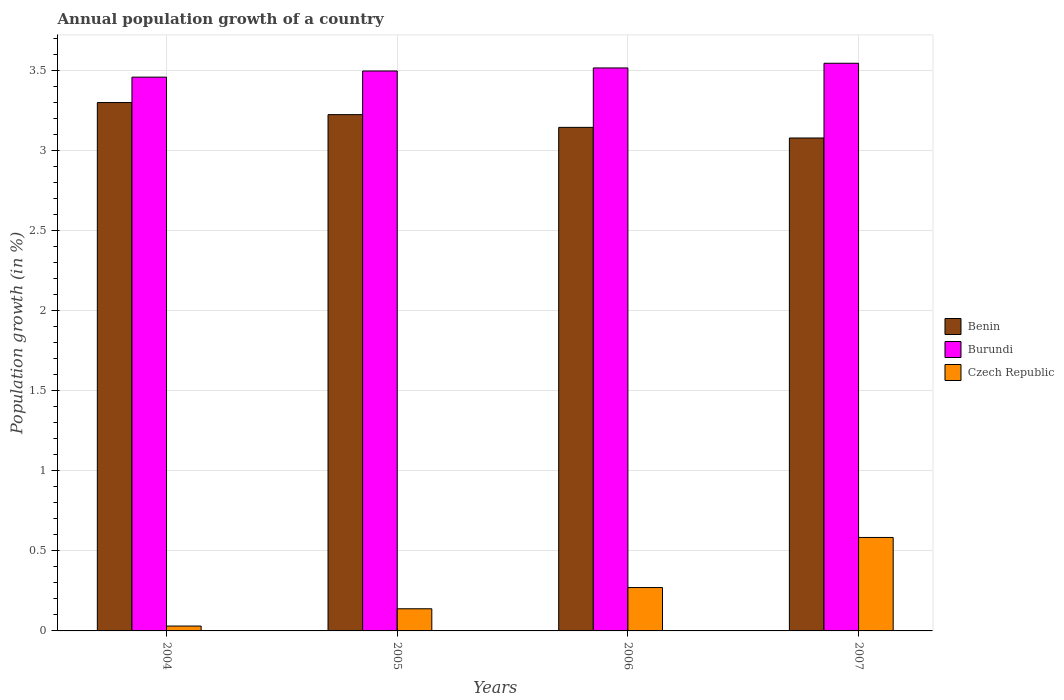Are the number of bars per tick equal to the number of legend labels?
Provide a short and direct response. Yes. How many bars are there on the 4th tick from the right?
Your response must be concise. 3. What is the annual population growth in Burundi in 2005?
Keep it short and to the point. 3.5. Across all years, what is the maximum annual population growth in Benin?
Give a very brief answer. 3.3. Across all years, what is the minimum annual population growth in Burundi?
Give a very brief answer. 3.46. What is the total annual population growth in Czech Republic in the graph?
Ensure brevity in your answer.  1.02. What is the difference between the annual population growth in Czech Republic in 2005 and that in 2006?
Provide a short and direct response. -0.13. What is the difference between the annual population growth in Burundi in 2007 and the annual population growth in Czech Republic in 2006?
Provide a short and direct response. 3.27. What is the average annual population growth in Czech Republic per year?
Offer a very short reply. 0.26. In the year 2007, what is the difference between the annual population growth in Czech Republic and annual population growth in Burundi?
Offer a very short reply. -2.96. In how many years, is the annual population growth in Benin greater than 1.8 %?
Give a very brief answer. 4. What is the ratio of the annual population growth in Burundi in 2004 to that in 2006?
Make the answer very short. 0.98. Is the difference between the annual population growth in Czech Republic in 2005 and 2007 greater than the difference between the annual population growth in Burundi in 2005 and 2007?
Offer a very short reply. No. What is the difference between the highest and the second highest annual population growth in Czech Republic?
Offer a terse response. 0.31. What is the difference between the highest and the lowest annual population growth in Benin?
Offer a very short reply. 0.22. What does the 1st bar from the left in 2006 represents?
Your answer should be compact. Benin. What does the 2nd bar from the right in 2004 represents?
Your response must be concise. Burundi. Is it the case that in every year, the sum of the annual population growth in Burundi and annual population growth in Benin is greater than the annual population growth in Czech Republic?
Your response must be concise. Yes. How many bars are there?
Your answer should be compact. 12. How many years are there in the graph?
Provide a short and direct response. 4. What is the difference between two consecutive major ticks on the Y-axis?
Keep it short and to the point. 0.5. Are the values on the major ticks of Y-axis written in scientific E-notation?
Give a very brief answer. No. Does the graph contain any zero values?
Give a very brief answer. No. Where does the legend appear in the graph?
Keep it short and to the point. Center right. What is the title of the graph?
Give a very brief answer. Annual population growth of a country. What is the label or title of the X-axis?
Provide a succinct answer. Years. What is the label or title of the Y-axis?
Provide a succinct answer. Population growth (in %). What is the Population growth (in %) of Benin in 2004?
Offer a very short reply. 3.3. What is the Population growth (in %) of Burundi in 2004?
Ensure brevity in your answer.  3.46. What is the Population growth (in %) of Czech Republic in 2004?
Offer a very short reply. 0.03. What is the Population growth (in %) of Benin in 2005?
Provide a succinct answer. 3.22. What is the Population growth (in %) of Burundi in 2005?
Keep it short and to the point. 3.5. What is the Population growth (in %) of Czech Republic in 2005?
Make the answer very short. 0.14. What is the Population growth (in %) in Benin in 2006?
Your answer should be very brief. 3.14. What is the Population growth (in %) in Burundi in 2006?
Make the answer very short. 3.52. What is the Population growth (in %) of Czech Republic in 2006?
Make the answer very short. 0.27. What is the Population growth (in %) of Benin in 2007?
Provide a succinct answer. 3.08. What is the Population growth (in %) in Burundi in 2007?
Your response must be concise. 3.54. What is the Population growth (in %) of Czech Republic in 2007?
Ensure brevity in your answer.  0.58. Across all years, what is the maximum Population growth (in %) in Benin?
Provide a succinct answer. 3.3. Across all years, what is the maximum Population growth (in %) in Burundi?
Your answer should be very brief. 3.54. Across all years, what is the maximum Population growth (in %) in Czech Republic?
Provide a short and direct response. 0.58. Across all years, what is the minimum Population growth (in %) of Benin?
Offer a very short reply. 3.08. Across all years, what is the minimum Population growth (in %) of Burundi?
Your response must be concise. 3.46. Across all years, what is the minimum Population growth (in %) of Czech Republic?
Provide a short and direct response. 0.03. What is the total Population growth (in %) in Benin in the graph?
Keep it short and to the point. 12.74. What is the total Population growth (in %) of Burundi in the graph?
Give a very brief answer. 14.01. What is the total Population growth (in %) in Czech Republic in the graph?
Your answer should be compact. 1.02. What is the difference between the Population growth (in %) of Benin in 2004 and that in 2005?
Offer a terse response. 0.08. What is the difference between the Population growth (in %) of Burundi in 2004 and that in 2005?
Your response must be concise. -0.04. What is the difference between the Population growth (in %) in Czech Republic in 2004 and that in 2005?
Provide a short and direct response. -0.11. What is the difference between the Population growth (in %) in Benin in 2004 and that in 2006?
Your answer should be compact. 0.15. What is the difference between the Population growth (in %) in Burundi in 2004 and that in 2006?
Provide a succinct answer. -0.06. What is the difference between the Population growth (in %) of Czech Republic in 2004 and that in 2006?
Provide a succinct answer. -0.24. What is the difference between the Population growth (in %) of Benin in 2004 and that in 2007?
Your answer should be compact. 0.22. What is the difference between the Population growth (in %) in Burundi in 2004 and that in 2007?
Provide a short and direct response. -0.09. What is the difference between the Population growth (in %) in Czech Republic in 2004 and that in 2007?
Offer a terse response. -0.55. What is the difference between the Population growth (in %) of Benin in 2005 and that in 2006?
Provide a succinct answer. 0.08. What is the difference between the Population growth (in %) of Burundi in 2005 and that in 2006?
Make the answer very short. -0.02. What is the difference between the Population growth (in %) in Czech Republic in 2005 and that in 2006?
Make the answer very short. -0.13. What is the difference between the Population growth (in %) in Benin in 2005 and that in 2007?
Keep it short and to the point. 0.15. What is the difference between the Population growth (in %) of Burundi in 2005 and that in 2007?
Your answer should be compact. -0.05. What is the difference between the Population growth (in %) in Czech Republic in 2005 and that in 2007?
Provide a succinct answer. -0.45. What is the difference between the Population growth (in %) of Benin in 2006 and that in 2007?
Keep it short and to the point. 0.07. What is the difference between the Population growth (in %) in Burundi in 2006 and that in 2007?
Provide a succinct answer. -0.03. What is the difference between the Population growth (in %) of Czech Republic in 2006 and that in 2007?
Ensure brevity in your answer.  -0.31. What is the difference between the Population growth (in %) of Benin in 2004 and the Population growth (in %) of Burundi in 2005?
Offer a very short reply. -0.2. What is the difference between the Population growth (in %) in Benin in 2004 and the Population growth (in %) in Czech Republic in 2005?
Provide a succinct answer. 3.16. What is the difference between the Population growth (in %) of Burundi in 2004 and the Population growth (in %) of Czech Republic in 2005?
Your response must be concise. 3.32. What is the difference between the Population growth (in %) in Benin in 2004 and the Population growth (in %) in Burundi in 2006?
Offer a very short reply. -0.22. What is the difference between the Population growth (in %) in Benin in 2004 and the Population growth (in %) in Czech Republic in 2006?
Make the answer very short. 3.03. What is the difference between the Population growth (in %) in Burundi in 2004 and the Population growth (in %) in Czech Republic in 2006?
Give a very brief answer. 3.19. What is the difference between the Population growth (in %) of Benin in 2004 and the Population growth (in %) of Burundi in 2007?
Provide a succinct answer. -0.25. What is the difference between the Population growth (in %) of Benin in 2004 and the Population growth (in %) of Czech Republic in 2007?
Your response must be concise. 2.72. What is the difference between the Population growth (in %) of Burundi in 2004 and the Population growth (in %) of Czech Republic in 2007?
Provide a succinct answer. 2.87. What is the difference between the Population growth (in %) in Benin in 2005 and the Population growth (in %) in Burundi in 2006?
Your answer should be very brief. -0.29. What is the difference between the Population growth (in %) of Benin in 2005 and the Population growth (in %) of Czech Republic in 2006?
Provide a succinct answer. 2.95. What is the difference between the Population growth (in %) in Burundi in 2005 and the Population growth (in %) in Czech Republic in 2006?
Your answer should be very brief. 3.23. What is the difference between the Population growth (in %) in Benin in 2005 and the Population growth (in %) in Burundi in 2007?
Make the answer very short. -0.32. What is the difference between the Population growth (in %) of Benin in 2005 and the Population growth (in %) of Czech Republic in 2007?
Provide a short and direct response. 2.64. What is the difference between the Population growth (in %) in Burundi in 2005 and the Population growth (in %) in Czech Republic in 2007?
Provide a short and direct response. 2.91. What is the difference between the Population growth (in %) of Benin in 2006 and the Population growth (in %) of Burundi in 2007?
Your response must be concise. -0.4. What is the difference between the Population growth (in %) in Benin in 2006 and the Population growth (in %) in Czech Republic in 2007?
Offer a very short reply. 2.56. What is the difference between the Population growth (in %) in Burundi in 2006 and the Population growth (in %) in Czech Republic in 2007?
Provide a succinct answer. 2.93. What is the average Population growth (in %) in Benin per year?
Your response must be concise. 3.19. What is the average Population growth (in %) of Burundi per year?
Make the answer very short. 3.5. What is the average Population growth (in %) of Czech Republic per year?
Keep it short and to the point. 0.26. In the year 2004, what is the difference between the Population growth (in %) in Benin and Population growth (in %) in Burundi?
Provide a short and direct response. -0.16. In the year 2004, what is the difference between the Population growth (in %) in Benin and Population growth (in %) in Czech Republic?
Provide a short and direct response. 3.27. In the year 2004, what is the difference between the Population growth (in %) in Burundi and Population growth (in %) in Czech Republic?
Make the answer very short. 3.43. In the year 2005, what is the difference between the Population growth (in %) of Benin and Population growth (in %) of Burundi?
Your answer should be very brief. -0.27. In the year 2005, what is the difference between the Population growth (in %) of Benin and Population growth (in %) of Czech Republic?
Make the answer very short. 3.09. In the year 2005, what is the difference between the Population growth (in %) of Burundi and Population growth (in %) of Czech Republic?
Make the answer very short. 3.36. In the year 2006, what is the difference between the Population growth (in %) of Benin and Population growth (in %) of Burundi?
Your response must be concise. -0.37. In the year 2006, what is the difference between the Population growth (in %) in Benin and Population growth (in %) in Czech Republic?
Ensure brevity in your answer.  2.87. In the year 2006, what is the difference between the Population growth (in %) of Burundi and Population growth (in %) of Czech Republic?
Your response must be concise. 3.24. In the year 2007, what is the difference between the Population growth (in %) in Benin and Population growth (in %) in Burundi?
Your answer should be compact. -0.47. In the year 2007, what is the difference between the Population growth (in %) in Benin and Population growth (in %) in Czech Republic?
Offer a terse response. 2.49. In the year 2007, what is the difference between the Population growth (in %) in Burundi and Population growth (in %) in Czech Republic?
Your answer should be very brief. 2.96. What is the ratio of the Population growth (in %) in Benin in 2004 to that in 2005?
Your answer should be compact. 1.02. What is the ratio of the Population growth (in %) in Czech Republic in 2004 to that in 2005?
Your response must be concise. 0.22. What is the ratio of the Population growth (in %) in Benin in 2004 to that in 2006?
Your response must be concise. 1.05. What is the ratio of the Population growth (in %) of Burundi in 2004 to that in 2006?
Provide a short and direct response. 0.98. What is the ratio of the Population growth (in %) in Czech Republic in 2004 to that in 2006?
Your response must be concise. 0.11. What is the ratio of the Population growth (in %) of Benin in 2004 to that in 2007?
Offer a terse response. 1.07. What is the ratio of the Population growth (in %) of Burundi in 2004 to that in 2007?
Provide a short and direct response. 0.98. What is the ratio of the Population growth (in %) in Czech Republic in 2004 to that in 2007?
Provide a succinct answer. 0.05. What is the ratio of the Population growth (in %) in Benin in 2005 to that in 2006?
Your answer should be very brief. 1.03. What is the ratio of the Population growth (in %) in Czech Republic in 2005 to that in 2006?
Give a very brief answer. 0.51. What is the ratio of the Population growth (in %) in Benin in 2005 to that in 2007?
Keep it short and to the point. 1.05. What is the ratio of the Population growth (in %) in Burundi in 2005 to that in 2007?
Give a very brief answer. 0.99. What is the ratio of the Population growth (in %) of Czech Republic in 2005 to that in 2007?
Your answer should be very brief. 0.24. What is the ratio of the Population growth (in %) of Benin in 2006 to that in 2007?
Provide a succinct answer. 1.02. What is the ratio of the Population growth (in %) in Czech Republic in 2006 to that in 2007?
Give a very brief answer. 0.46. What is the difference between the highest and the second highest Population growth (in %) in Benin?
Ensure brevity in your answer.  0.08. What is the difference between the highest and the second highest Population growth (in %) of Burundi?
Your answer should be very brief. 0.03. What is the difference between the highest and the second highest Population growth (in %) of Czech Republic?
Your answer should be compact. 0.31. What is the difference between the highest and the lowest Population growth (in %) of Benin?
Make the answer very short. 0.22. What is the difference between the highest and the lowest Population growth (in %) of Burundi?
Provide a succinct answer. 0.09. What is the difference between the highest and the lowest Population growth (in %) of Czech Republic?
Your answer should be very brief. 0.55. 